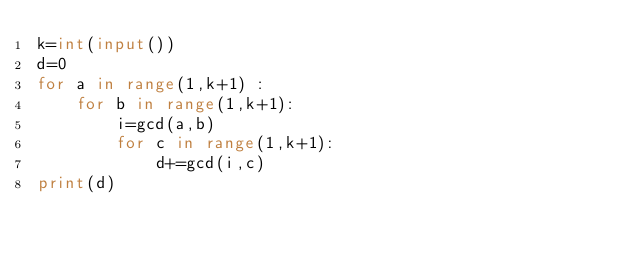Convert code to text. <code><loc_0><loc_0><loc_500><loc_500><_Python_>k=int(input())
d=0
for a in range(1,k+1) :
    for b in range(1,k+1):
        i=gcd(a,b)
        for c in range(1,k+1):
            d+=gcd(i,c)
print(d)
</code> 